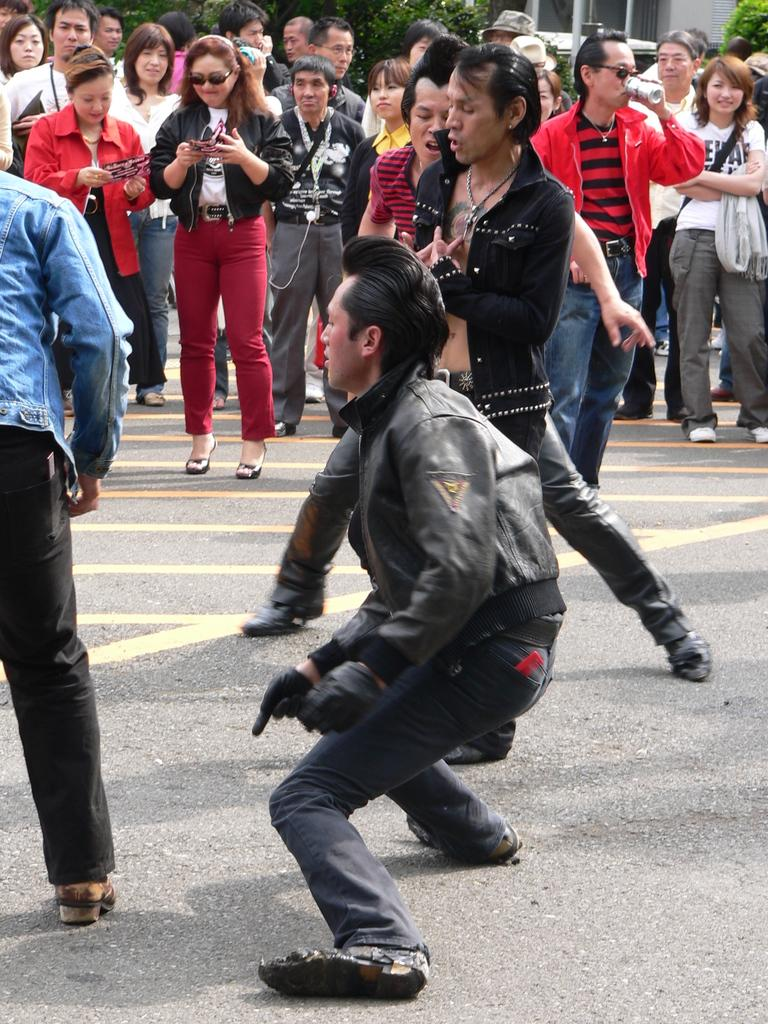How many people are in the image? There are persons in the image, but the exact number is not specified. What are some of the activities the persons are engaged in? Some of the persons are dancing, one person is drinking soda, and some persons are using mobiles. What can be seen in the background of the image? There is a house and trees in the background of the image. How many lizards are crawling on the person drinking soda in the image? There are no lizards present in the image; only persons, dancing, soda drinking, mobile usage, a house, and trees are mentioned. What type of string is being used by the person dancing in the image? There is no mention of string or any object being used by the person dancing in the image. 